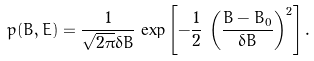<formula> <loc_0><loc_0><loc_500><loc_500>p ( B , E ) = \frac { 1 } { \sqrt { 2 \pi } \delta B } \, \exp \left [ - \frac { 1 } { 2 } \, \left ( \frac { B - B _ { 0 } } { \delta B } \right ) ^ { 2 } \right ] .</formula> 